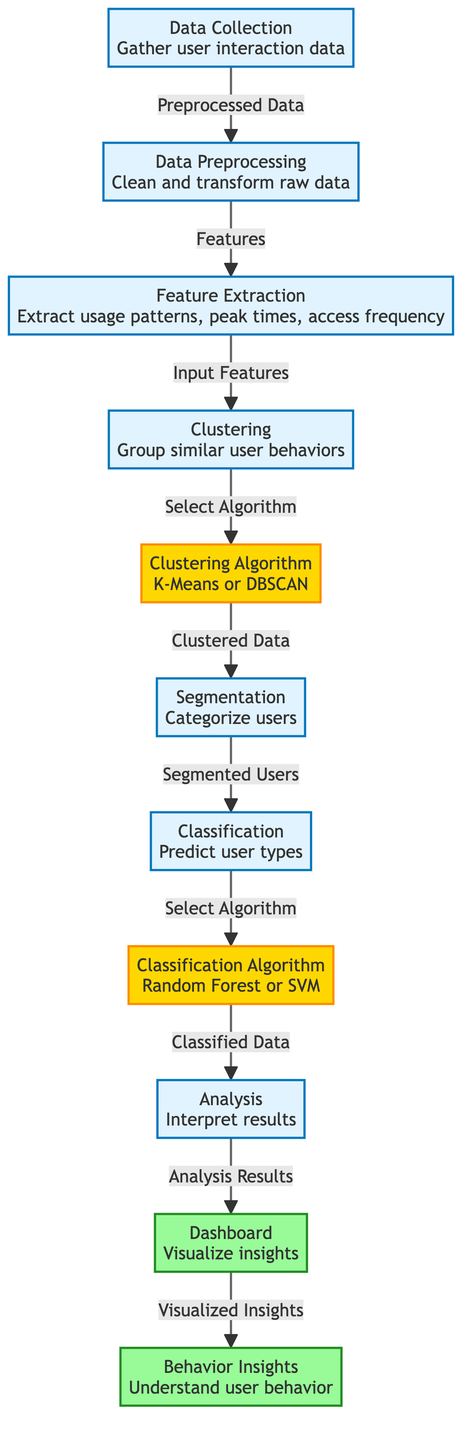What is the first step in the diagram? The diagram shows that the first step is "Data Collection," where user interaction data is gathered. It is the initial process that starts the flow.
Answer: Data Collection Which algorithm is used for clustering in the model? The diagram specifies "K-Means or DBSCAN" as the clustering algorithms. This indicates that either of these can be selected to group similar user behaviors.
Answer: K-Means or DBSCAN How many processes are involved in the user behavior analytics model? By counting the processes (nodes) in the diagram, we find there are seven distinct processes: Data Collection, Data Preprocessing, Feature Extraction, Clustering, Segmentation, Classification, and Analysis.
Answer: Seven What is the output result of the analysis? The output from the analysis phase is "Dashboard," where insights are visualized. This is the key output that presents the analysis results.
Answer: Dashboard What comes after segmentation in the workflow? After the segmentation step, the next step is "Classification." This means that once users are segmented, they are then categorized based on the learned behaviors.
Answer: Classification What is extracted during the feature extraction phase? In the feature extraction phase, "usage patterns, peak times, access frequency" are extracted. This indicates what specific features are evaluated from the raw data.
Answer: Usage patterns, peak times, access frequency Which output node follows the dashboard? The nodes following the dashboard is "Behavior Insights," which indicates that the visualized insights lead to an understanding of user behavior.
Answer: Behavior Insights What type of analysis is performed at the end of the workflow? The final type of analysis performed as depicted is simply referred to as "Analysis," which indicates interpretation of the results of the previous steps.
Answer: Analysis 